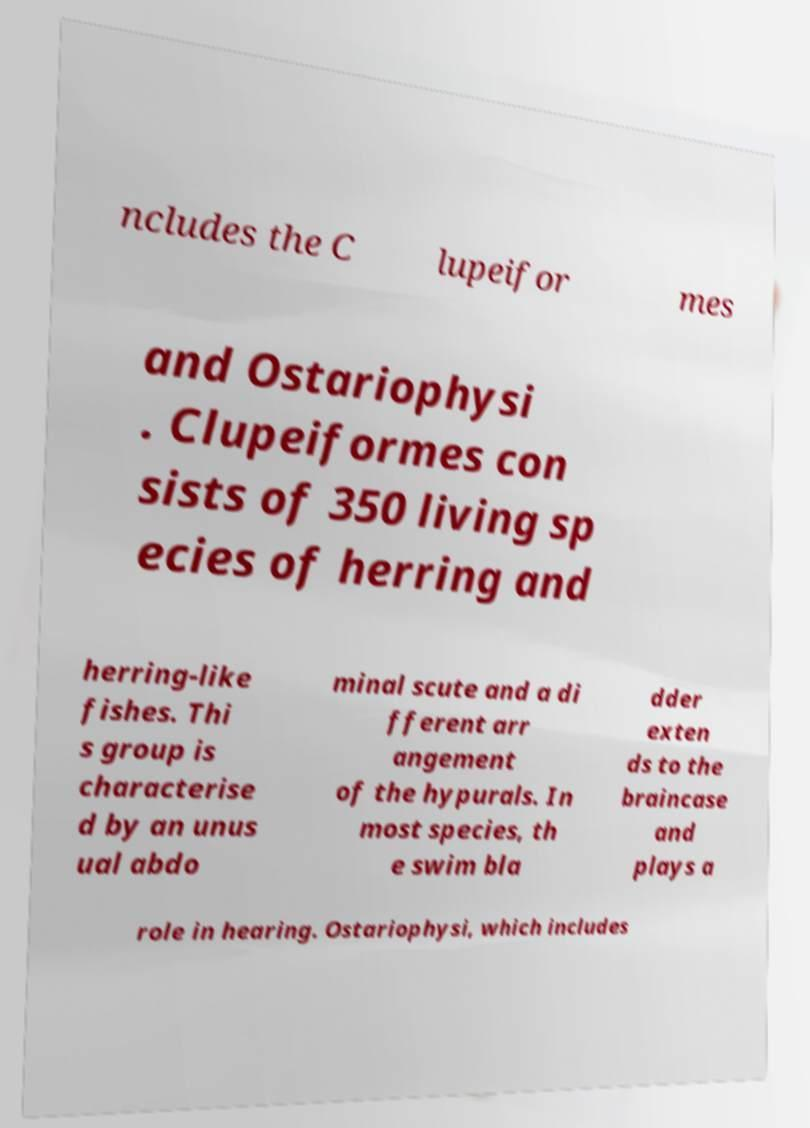Can you read and provide the text displayed in the image?This photo seems to have some interesting text. Can you extract and type it out for me? ncludes the C lupeifor mes and Ostariophysi . Clupeiformes con sists of 350 living sp ecies of herring and herring-like fishes. Thi s group is characterise d by an unus ual abdo minal scute and a di fferent arr angement of the hypurals. In most species, th e swim bla dder exten ds to the braincase and plays a role in hearing. Ostariophysi, which includes 